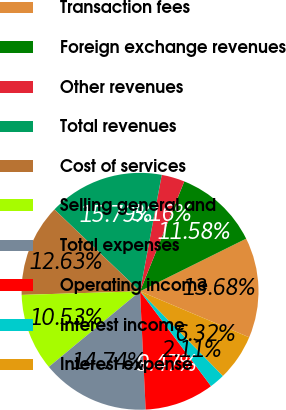Convert chart. <chart><loc_0><loc_0><loc_500><loc_500><pie_chart><fcel>Transaction fees<fcel>Foreign exchange revenues<fcel>Other revenues<fcel>Total revenues<fcel>Cost of services<fcel>Selling general and<fcel>Total expenses<fcel>Operating income<fcel>Interest income<fcel>Interest expense<nl><fcel>13.68%<fcel>11.58%<fcel>3.16%<fcel>15.79%<fcel>12.63%<fcel>10.53%<fcel>14.74%<fcel>9.47%<fcel>2.11%<fcel>6.32%<nl></chart> 